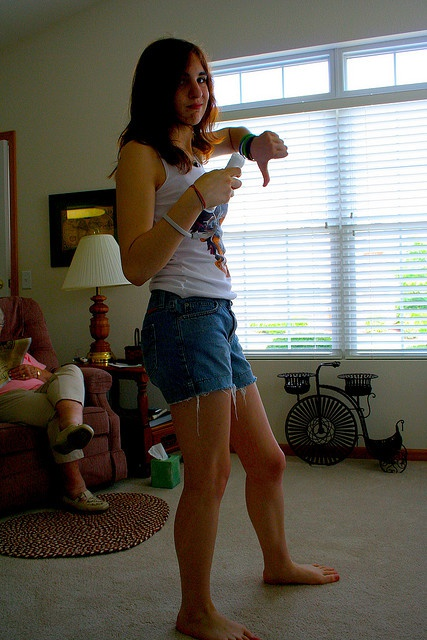Describe the objects in this image and their specific colors. I can see people in gray, black, and maroon tones, chair in gray, black, maroon, olive, and brown tones, people in gray, black, maroon, and olive tones, remote in gray, brown, and darkgray tones, and book in gray, black, and purple tones in this image. 